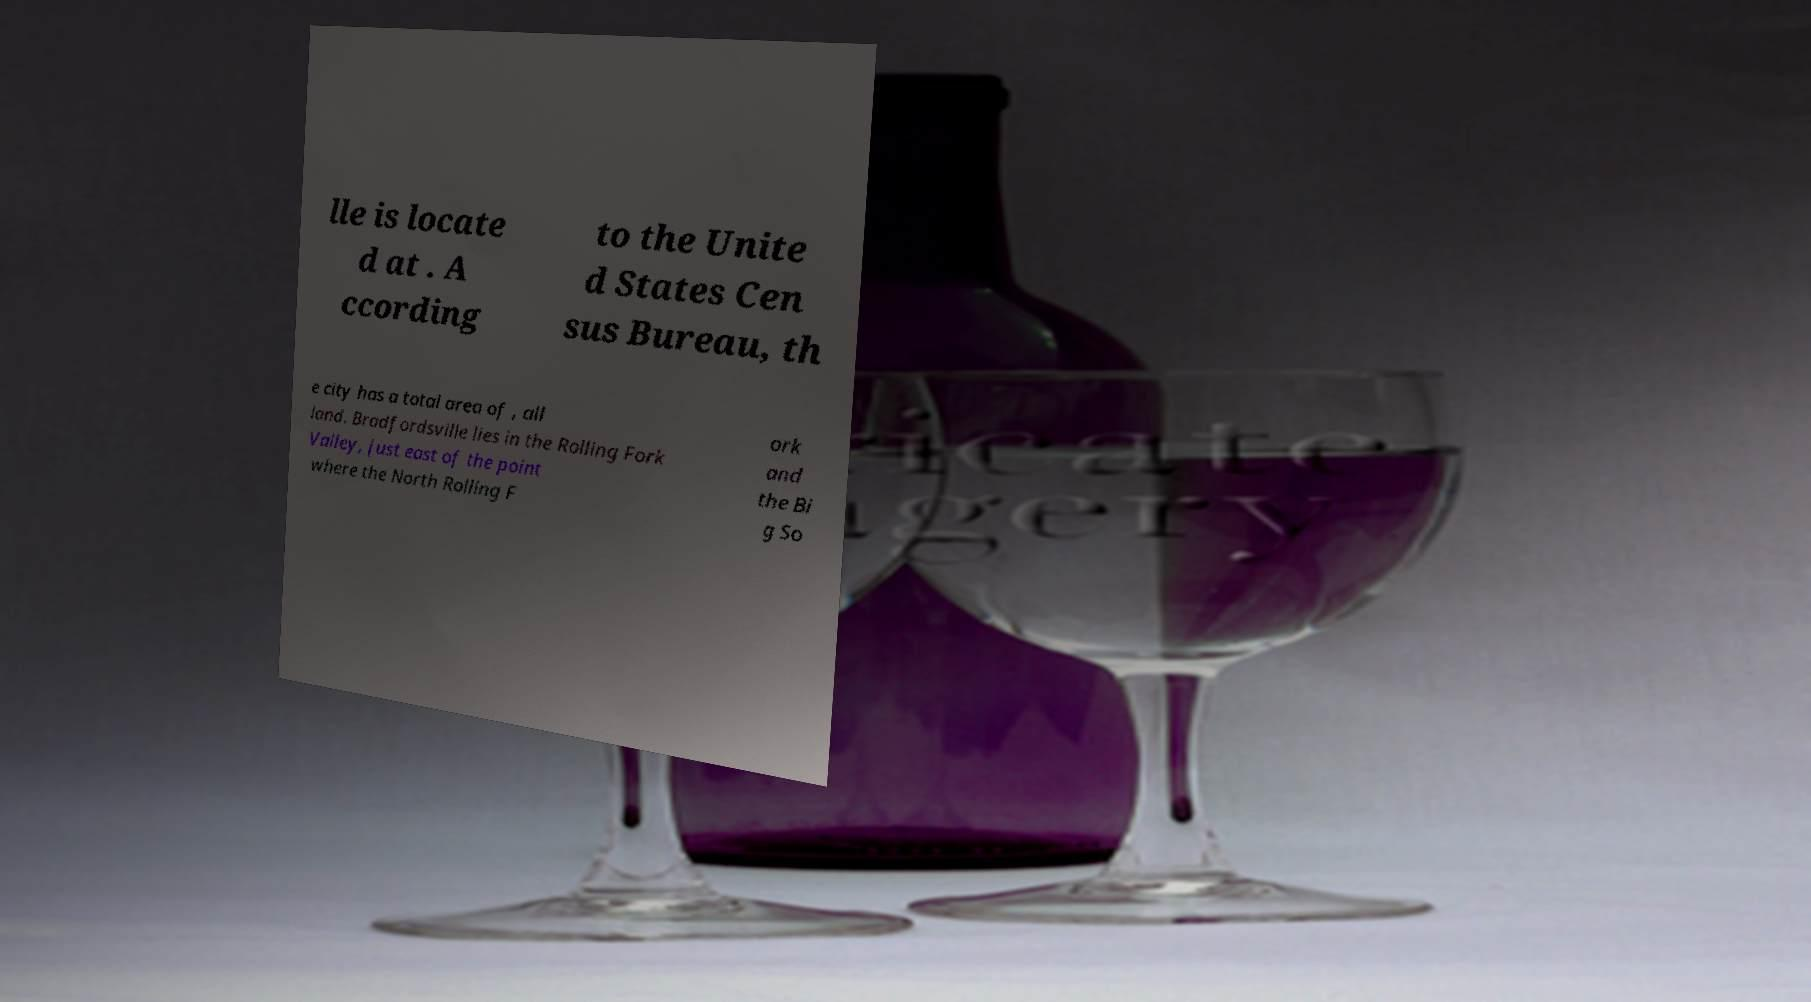Please identify and transcribe the text found in this image. lle is locate d at . A ccording to the Unite d States Cen sus Bureau, th e city has a total area of , all land. Bradfordsville lies in the Rolling Fork Valley, just east of the point where the North Rolling F ork and the Bi g So 